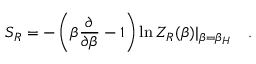Convert formula to latex. <formula><loc_0><loc_0><loc_500><loc_500>S _ { R } = - \left ( \beta { \frac { \partial } { \partial \beta } } - 1 \right ) \ln Z _ { R } ( \beta ) | _ { \beta = \beta _ { H } } .</formula> 